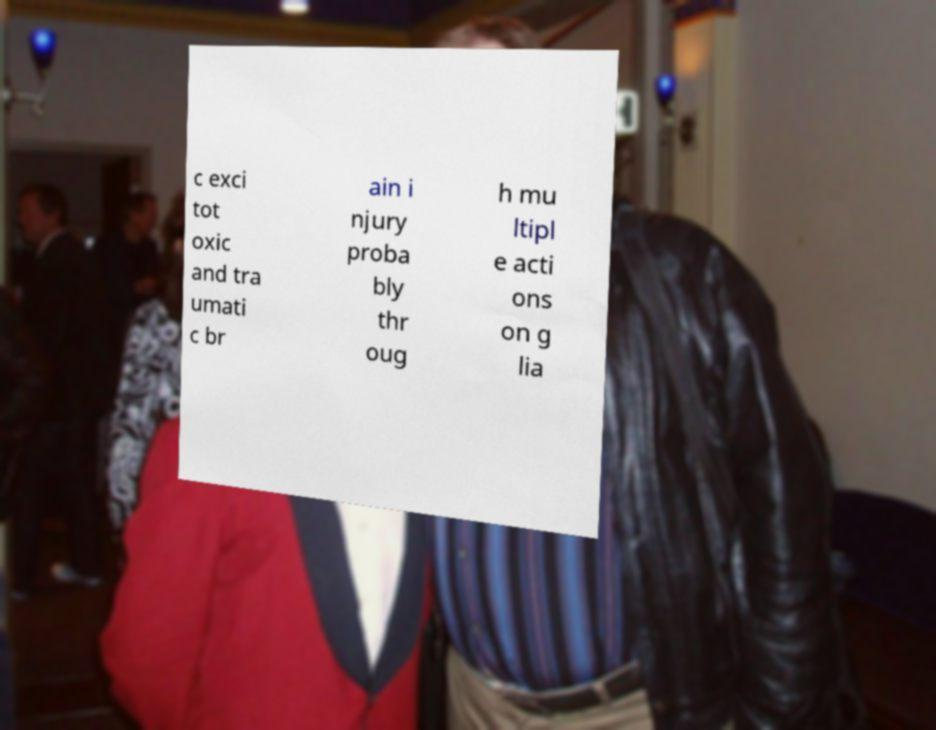Please identify and transcribe the text found in this image. c exci tot oxic and tra umati c br ain i njury proba bly thr oug h mu ltipl e acti ons on g lia 